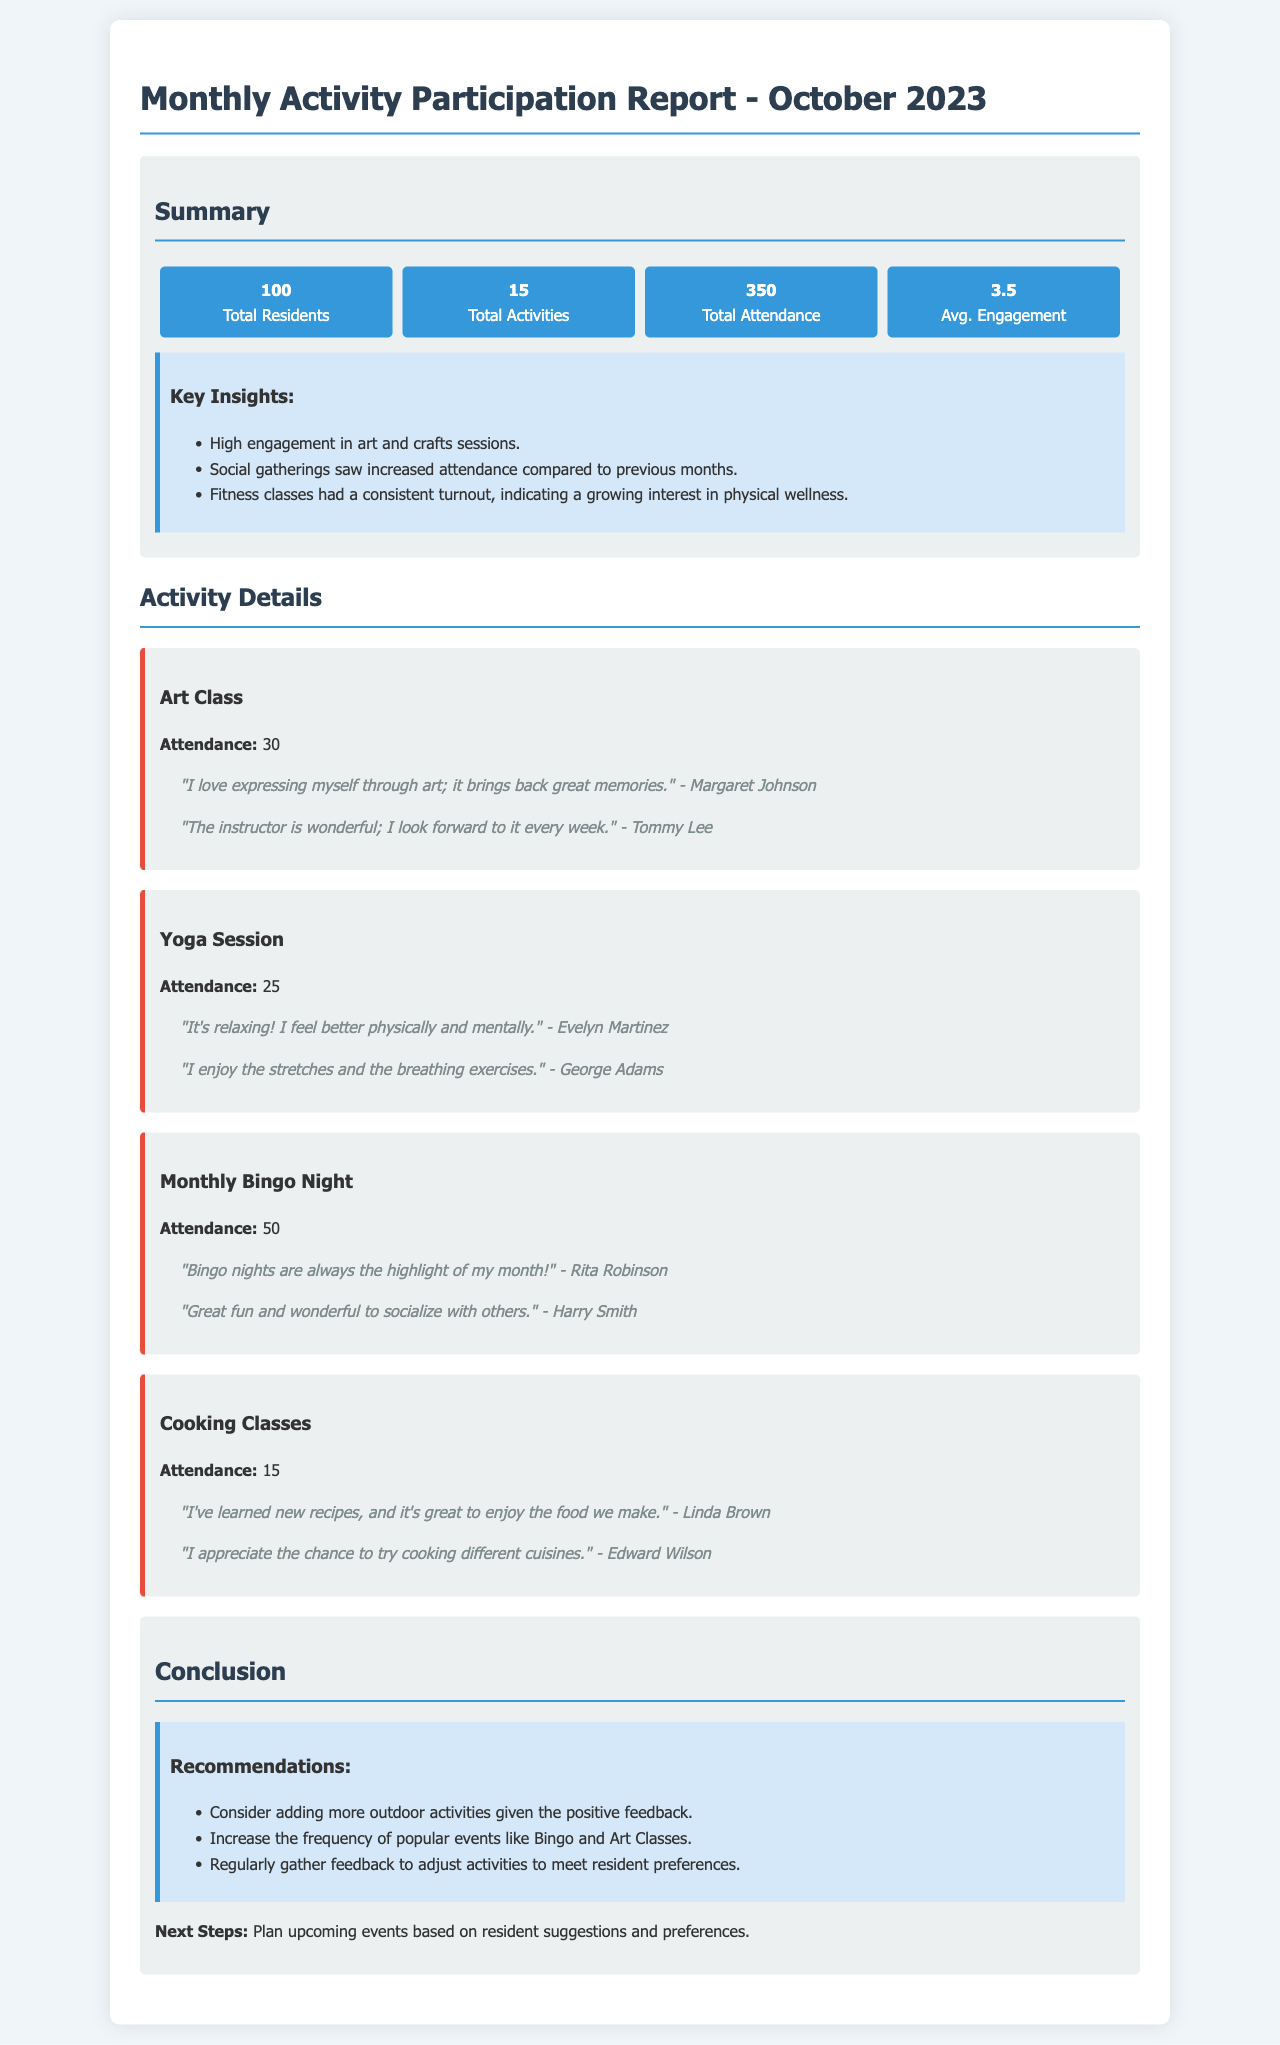What is the total number of residents? The total number of residents is explicitly stated in the summary section of the report.
Answer: 100 What was the attendance for the Monthly Bingo Night? The attendance figure for the Monthly Bingo Night is mentioned under the activity details section.
Answer: 50 Which activity had the highest attendance? The activity with the highest attendance is indicated in the activity details section, where attendance figures are provided for each activity.
Answer: Monthly Bingo Night What is the average engagement level? The average engagement level is provided in the summary section of the report.
Answer: 3.5 What specific feedback did a participant give regarding the Art Class? Feedback from participants is included in the activity details, which provides quotes from residents about their experiences.
Answer: "The instructor is wonderful; I look forward to it every week." - Tommy Lee Which activity had the lowest attendance? The lowest attendance is found in the activity details section, where each activity's attendance is listed.
Answer: Cooking Classes What are two recommendations given in the report? Recommendations are listed specifically in the conclusion section, which summarizes suggested actions based on participation and feedback.
Answer: Consider adding more outdoor activities, Increase the frequency of popular events like Bingo and Art Classes How many total activities were there? The total number of activities is provided in the summary section of the report.
Answer: 15 What is the feedback quote from Rita Robinson? Rita Robinson's feedback is included in the feedback section for the Monthly Bingo Night, which captures residents' comments.
Answer: "Bingo nights are always the highlight of my month!" - Rita Robinson 